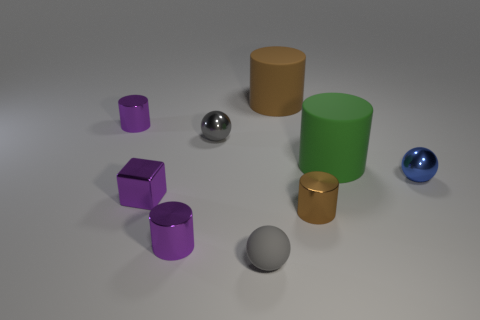Subtract all purple cylinders. How many cylinders are left? 3 Subtract all cubes. How many objects are left? 8 Subtract all green balls. How many green cylinders are left? 1 Subtract all metallic spheres. Subtract all purple cubes. How many objects are left? 6 Add 9 small purple cubes. How many small purple cubes are left? 10 Add 9 matte cubes. How many matte cubes exist? 9 Subtract all purple cylinders. How many cylinders are left? 3 Subtract 0 gray blocks. How many objects are left? 9 Subtract 5 cylinders. How many cylinders are left? 0 Subtract all cyan cubes. Subtract all cyan cylinders. How many cubes are left? 1 